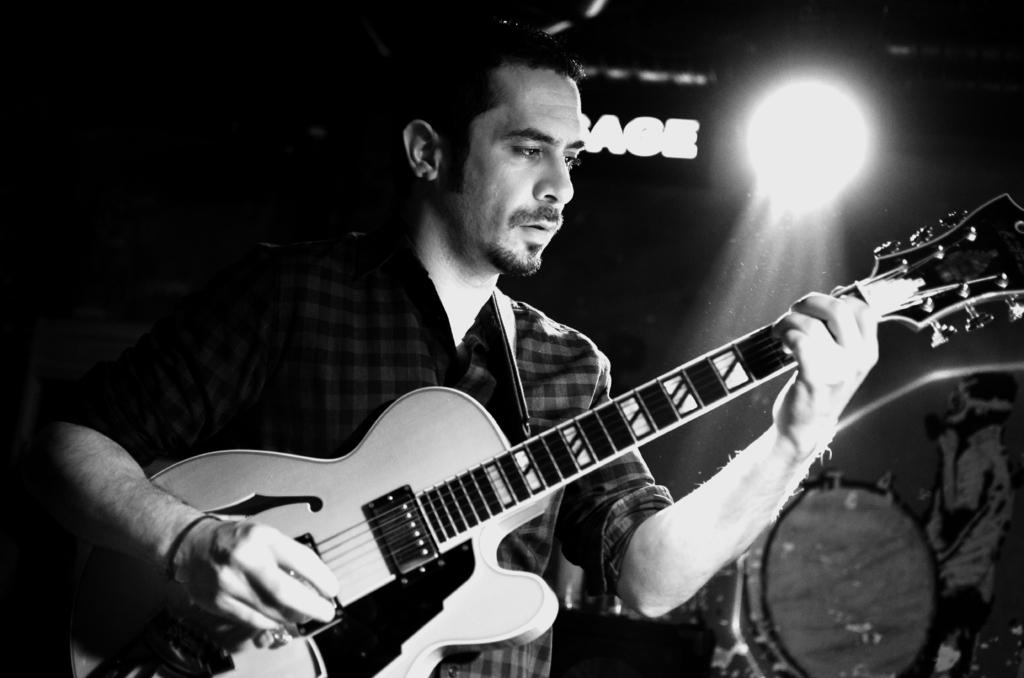What is the main subject of the image? There is a man in the image. What is the man holding in his left hand? The man is holding a guitar with his left hand. What is the man doing with his right hand? The man is playing the guitar with his right hand. What is the man's focus in the image? The man is looking at the guitar. What type of business is the man conducting in the image? There is no indication of a business in the image; it shows a man playing a guitar. How does the man use glue in the image? There is no glue present in the image, so it cannot be used or mentioned. 